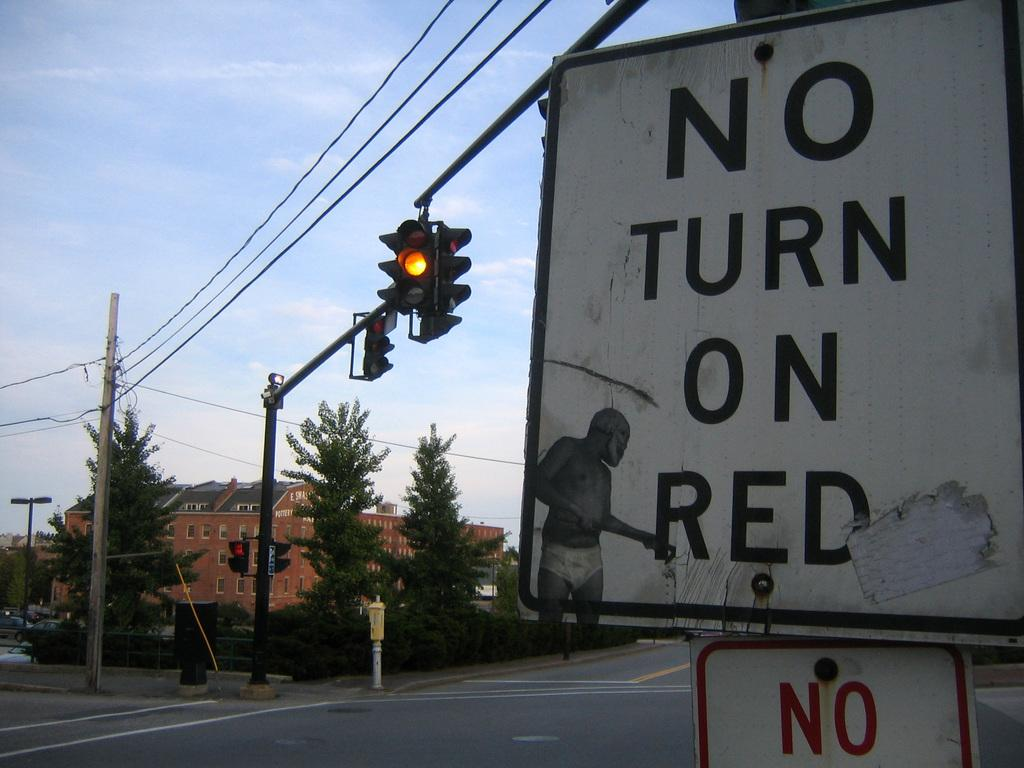<image>
Provide a brief description of the given image. A photo of a yellow light with a sign to the right of it that says no turn on red. 